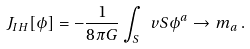Convert formula to latex. <formula><loc_0><loc_0><loc_500><loc_500>J _ { I H } [ \phi ] = - \frac { 1 } { 8 \pi G } \int _ { S } \ v S \phi ^ { a } \to m _ { a } \, .</formula> 